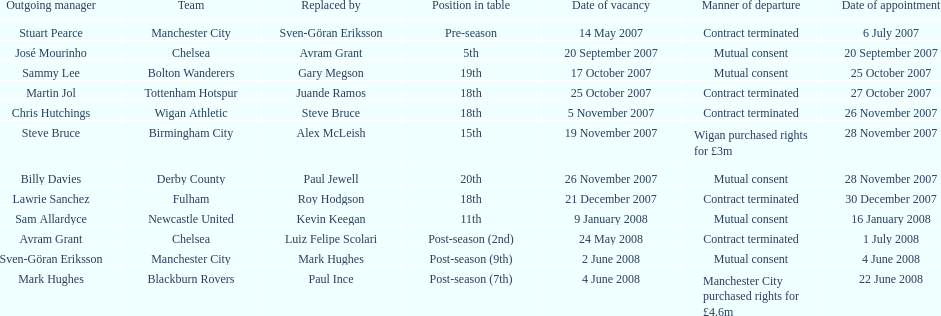Avram grant was with chelsea for at least how many years? 1. 